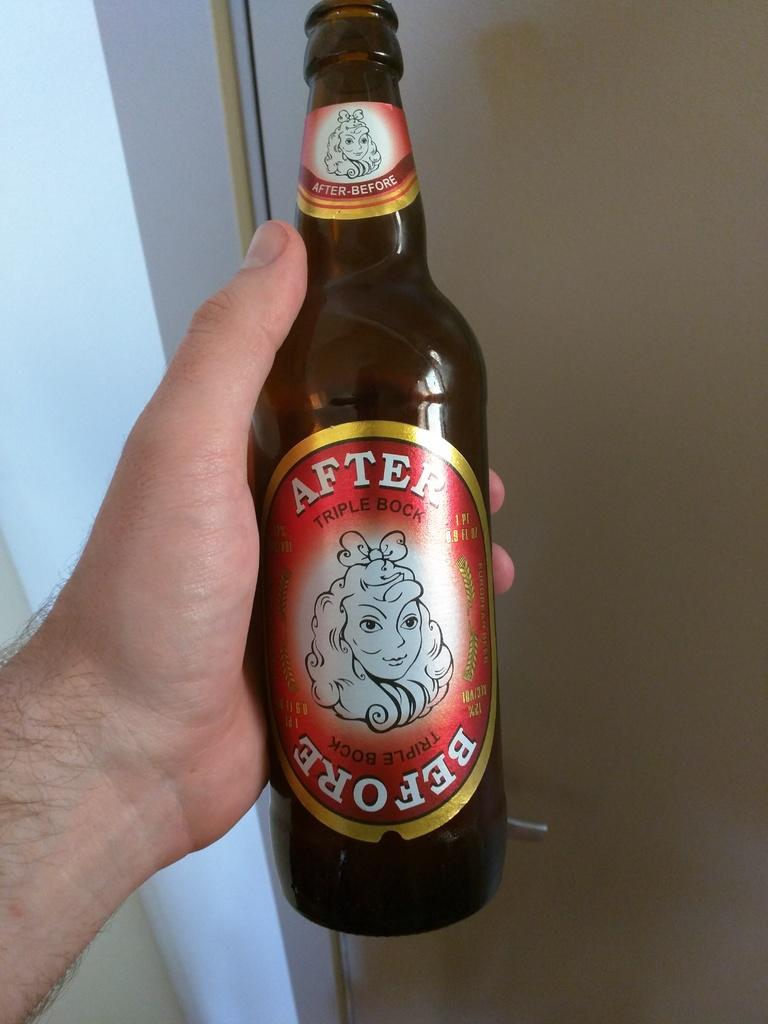<image>
Provide a brief description of the given image. A bottle of After Before triple bock beer with a drawing of a woman on the label. 